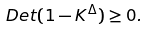Convert formula to latex. <formula><loc_0><loc_0><loc_500><loc_500>\ D e t ( 1 - K ^ { \Delta } ) \geq 0 .</formula> 